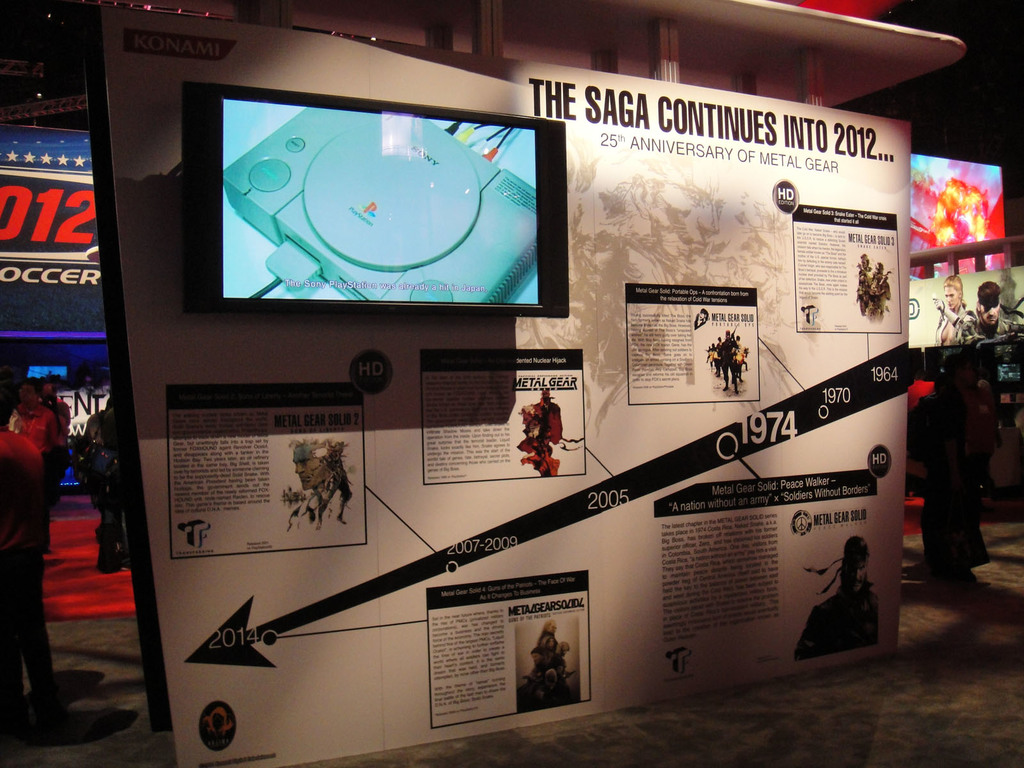What games are highlighted in the timeline displayed in the image? The timeline highlights several Metal Gear games including Metal Gear Solid 2 and Metal Gear Solid: Peace Walker. It notes significant releases and events from 1964 to 2014. Can you tell more about the significance of the year 2005 on this timeline? In 2005, Metal Gear Solid 3: Snake Eater, considered one of the most significant games in the series, was released, as noted on the displayed timeline. It presented a deep storyline set during the Cold War period. 